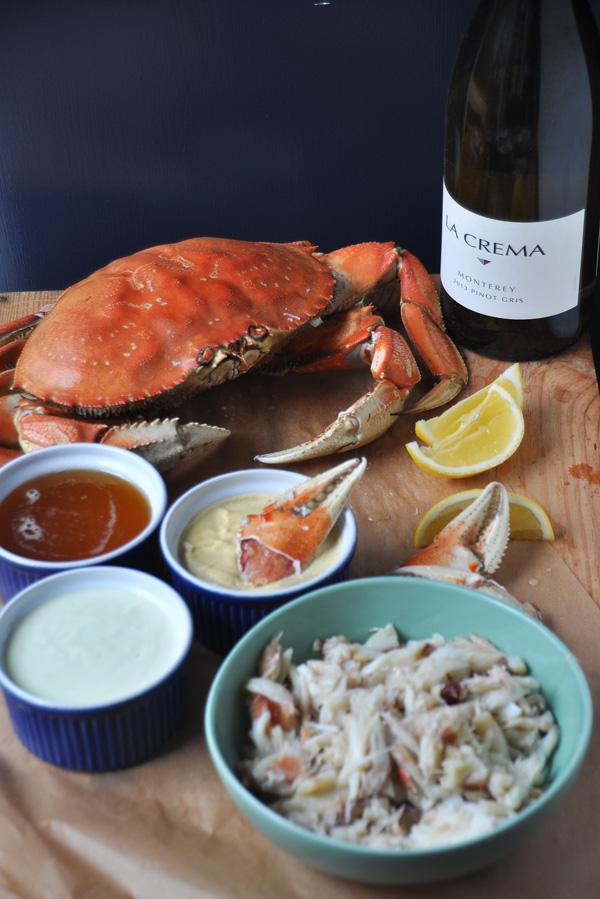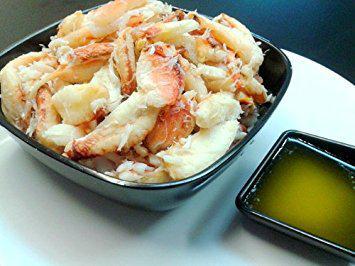The first image is the image on the left, the second image is the image on the right. Considering the images on both sides, is "One image shows forward facing red-orange crabs stacked up on chunky chips of ice instead of shaved ice." valid? Answer yes or no. No. The first image is the image on the left, the second image is the image on the right. For the images displayed, is the sentence "A meal of crabs sits near an alcoholic beverage in one of the images." factually correct? Answer yes or no. Yes. 